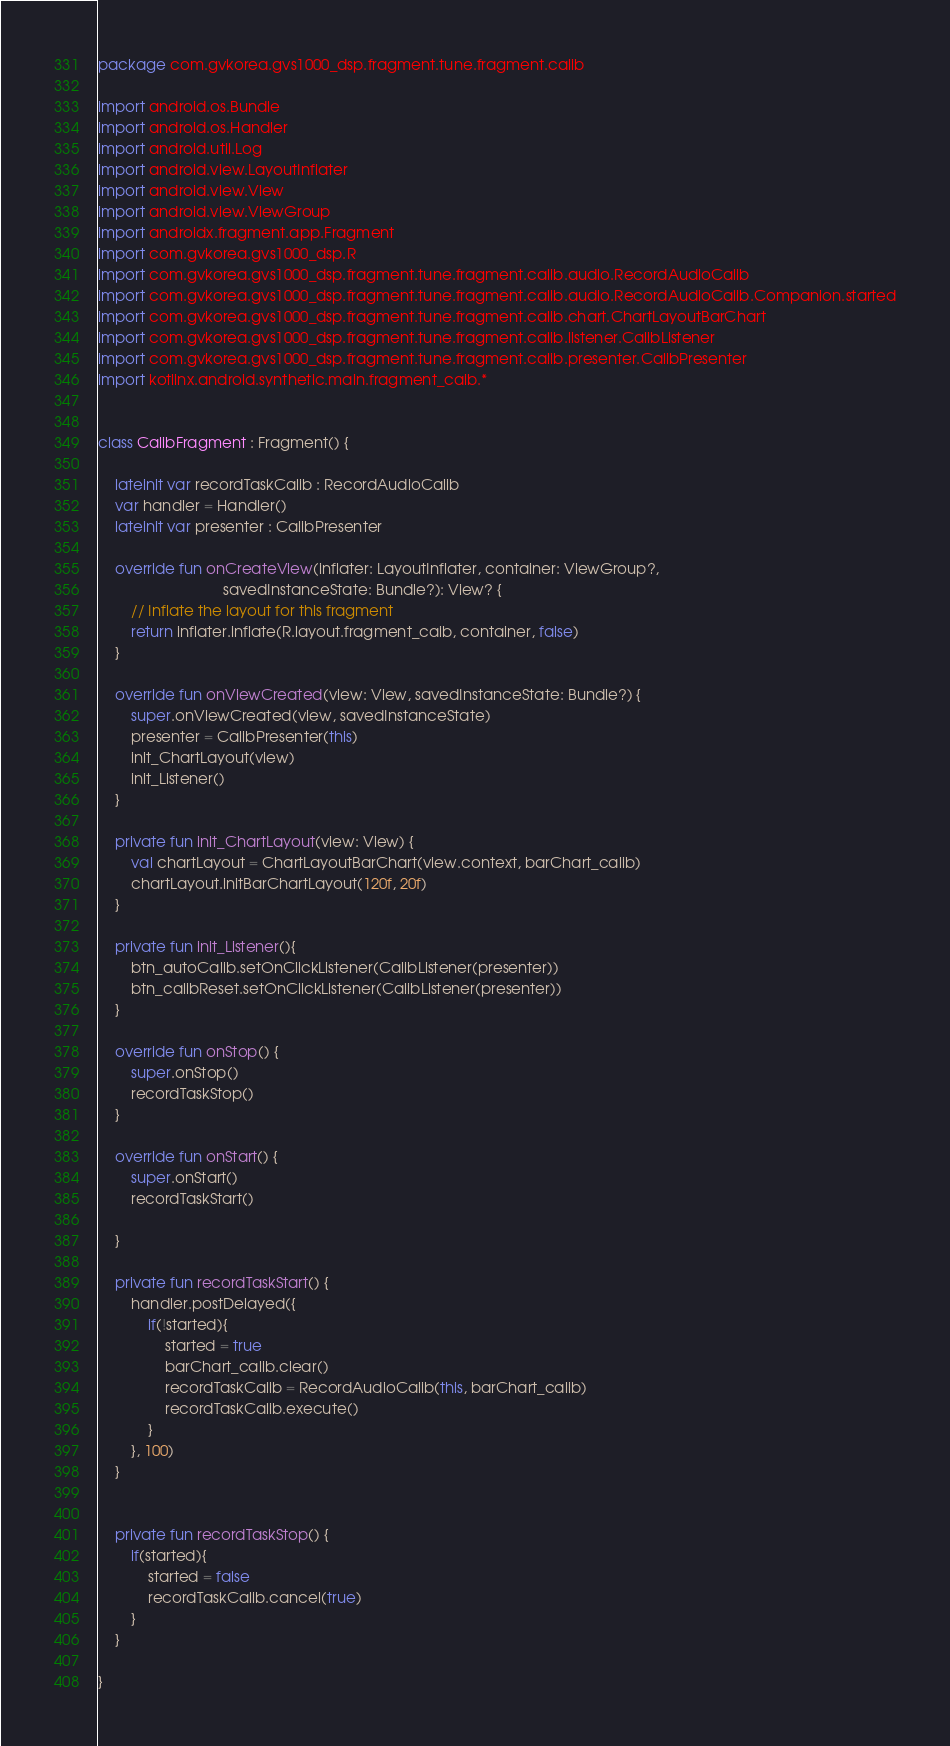Convert code to text. <code><loc_0><loc_0><loc_500><loc_500><_Kotlin_>package com.gvkorea.gvs1000_dsp.fragment.tune.fragment.calib

import android.os.Bundle
import android.os.Handler
import android.util.Log
import android.view.LayoutInflater
import android.view.View
import android.view.ViewGroup
import androidx.fragment.app.Fragment
import com.gvkorea.gvs1000_dsp.R
import com.gvkorea.gvs1000_dsp.fragment.tune.fragment.calib.audio.RecordAudioCalib
import com.gvkorea.gvs1000_dsp.fragment.tune.fragment.calib.audio.RecordAudioCalib.Companion.started
import com.gvkorea.gvs1000_dsp.fragment.tune.fragment.calib.chart.ChartLayoutBarChart
import com.gvkorea.gvs1000_dsp.fragment.tune.fragment.calib.listener.CalibListener
import com.gvkorea.gvs1000_dsp.fragment.tune.fragment.calib.presenter.CalibPresenter
import kotlinx.android.synthetic.main.fragment_caib.*


class CalibFragment : Fragment() {

    lateinit var recordTaskCalib : RecordAudioCalib
    var handler = Handler()
    lateinit var presenter : CalibPresenter

    override fun onCreateView(inflater: LayoutInflater, container: ViewGroup?,
                              savedInstanceState: Bundle?): View? {
        // Inflate the layout for this fragment
        return inflater.inflate(R.layout.fragment_caib, container, false)
    }

    override fun onViewCreated(view: View, savedInstanceState: Bundle?) {
        super.onViewCreated(view, savedInstanceState)
        presenter = CalibPresenter(this)
        init_ChartLayout(view)
        init_Listener()
    }

    private fun init_ChartLayout(view: View) {
        val chartLayout = ChartLayoutBarChart(view.context, barChart_calib)
        chartLayout.initBarChartLayout(120f, 20f)
    }

    private fun init_Listener(){
        btn_autoCalib.setOnClickListener(CalibListener(presenter))
        btn_calibReset.setOnClickListener(CalibListener(presenter))
    }

    override fun onStop() {
        super.onStop()
        recordTaskStop()
    }

    override fun onStart() {
        super.onStart()
        recordTaskStart()

    }

    private fun recordTaskStart() {
        handler.postDelayed({
            if(!started){
                started = true
                barChart_calib.clear()
                recordTaskCalib = RecordAudioCalib(this, barChart_calib)
                recordTaskCalib.execute()
            }
        }, 100)
    }


    private fun recordTaskStop() {
        if(started){
            started = false
            recordTaskCalib.cancel(true)
        }
    }

}
</code> 